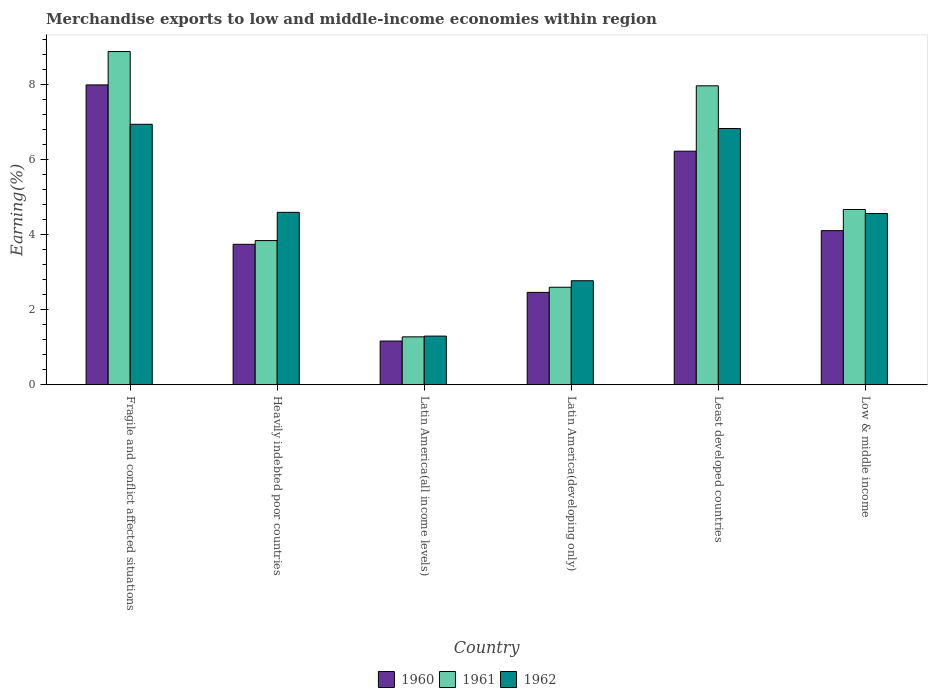How many different coloured bars are there?
Your answer should be very brief. 3. Are the number of bars per tick equal to the number of legend labels?
Your answer should be very brief. Yes. How many bars are there on the 1st tick from the left?
Ensure brevity in your answer.  3. How many bars are there on the 6th tick from the right?
Provide a short and direct response. 3. In how many cases, is the number of bars for a given country not equal to the number of legend labels?
Give a very brief answer. 0. What is the percentage of amount earned from merchandise exports in 1961 in Latin America(developing only)?
Your response must be concise. 2.6. Across all countries, what is the maximum percentage of amount earned from merchandise exports in 1961?
Offer a very short reply. 8.89. Across all countries, what is the minimum percentage of amount earned from merchandise exports in 1961?
Offer a terse response. 1.28. In which country was the percentage of amount earned from merchandise exports in 1960 maximum?
Ensure brevity in your answer.  Fragile and conflict affected situations. In which country was the percentage of amount earned from merchandise exports in 1960 minimum?
Make the answer very short. Latin America(all income levels). What is the total percentage of amount earned from merchandise exports in 1962 in the graph?
Give a very brief answer. 27.04. What is the difference between the percentage of amount earned from merchandise exports in 1961 in Heavily indebted poor countries and that in Low & middle income?
Make the answer very short. -0.83. What is the difference between the percentage of amount earned from merchandise exports in 1962 in Least developed countries and the percentage of amount earned from merchandise exports in 1961 in Latin America(developing only)?
Offer a very short reply. 4.23. What is the average percentage of amount earned from merchandise exports in 1961 per country?
Provide a short and direct response. 4.88. What is the difference between the percentage of amount earned from merchandise exports of/in 1961 and percentage of amount earned from merchandise exports of/in 1962 in Latin America(developing only)?
Provide a succinct answer. -0.17. In how many countries, is the percentage of amount earned from merchandise exports in 1961 greater than 6.8 %?
Offer a very short reply. 2. What is the ratio of the percentage of amount earned from merchandise exports in 1960 in Heavily indebted poor countries to that in Least developed countries?
Make the answer very short. 0.6. Is the percentage of amount earned from merchandise exports in 1960 in Heavily indebted poor countries less than that in Low & middle income?
Provide a short and direct response. Yes. Is the difference between the percentage of amount earned from merchandise exports in 1961 in Heavily indebted poor countries and Latin America(all income levels) greater than the difference between the percentage of amount earned from merchandise exports in 1962 in Heavily indebted poor countries and Latin America(all income levels)?
Offer a very short reply. No. What is the difference between the highest and the second highest percentage of amount earned from merchandise exports in 1961?
Keep it short and to the point. 4.21. What is the difference between the highest and the lowest percentage of amount earned from merchandise exports in 1961?
Make the answer very short. 7.61. In how many countries, is the percentage of amount earned from merchandise exports in 1962 greater than the average percentage of amount earned from merchandise exports in 1962 taken over all countries?
Give a very brief answer. 4. Is the sum of the percentage of amount earned from merchandise exports in 1962 in Latin America(developing only) and Least developed countries greater than the maximum percentage of amount earned from merchandise exports in 1961 across all countries?
Your answer should be compact. Yes. What does the 3rd bar from the left in Low & middle income represents?
Offer a very short reply. 1962. What does the 2nd bar from the right in Latin America(developing only) represents?
Make the answer very short. 1961. How many bars are there?
Keep it short and to the point. 18. What is the difference between two consecutive major ticks on the Y-axis?
Keep it short and to the point. 2. Does the graph contain any zero values?
Offer a terse response. No. Where does the legend appear in the graph?
Your answer should be compact. Bottom center. How many legend labels are there?
Make the answer very short. 3. How are the legend labels stacked?
Make the answer very short. Horizontal. What is the title of the graph?
Your answer should be compact. Merchandise exports to low and middle-income economies within region. Does "2000" appear as one of the legend labels in the graph?
Offer a terse response. No. What is the label or title of the X-axis?
Your response must be concise. Country. What is the label or title of the Y-axis?
Offer a very short reply. Earning(%). What is the Earning(%) of 1960 in Fragile and conflict affected situations?
Make the answer very short. 8. What is the Earning(%) of 1961 in Fragile and conflict affected situations?
Your answer should be very brief. 8.89. What is the Earning(%) in 1962 in Fragile and conflict affected situations?
Your response must be concise. 6.95. What is the Earning(%) of 1960 in Heavily indebted poor countries?
Give a very brief answer. 3.75. What is the Earning(%) of 1961 in Heavily indebted poor countries?
Offer a very short reply. 3.85. What is the Earning(%) of 1962 in Heavily indebted poor countries?
Your answer should be very brief. 4.6. What is the Earning(%) in 1960 in Latin America(all income levels)?
Keep it short and to the point. 1.17. What is the Earning(%) in 1961 in Latin America(all income levels)?
Ensure brevity in your answer.  1.28. What is the Earning(%) of 1962 in Latin America(all income levels)?
Offer a terse response. 1.3. What is the Earning(%) of 1960 in Latin America(developing only)?
Provide a succinct answer. 2.47. What is the Earning(%) in 1961 in Latin America(developing only)?
Offer a very short reply. 2.6. What is the Earning(%) of 1962 in Latin America(developing only)?
Offer a terse response. 2.78. What is the Earning(%) in 1960 in Least developed countries?
Ensure brevity in your answer.  6.23. What is the Earning(%) in 1961 in Least developed countries?
Provide a short and direct response. 7.98. What is the Earning(%) in 1962 in Least developed countries?
Offer a very short reply. 6.84. What is the Earning(%) in 1960 in Low & middle income?
Make the answer very short. 4.11. What is the Earning(%) in 1961 in Low & middle income?
Your answer should be compact. 4.68. What is the Earning(%) of 1962 in Low & middle income?
Provide a short and direct response. 4.57. Across all countries, what is the maximum Earning(%) of 1960?
Your answer should be very brief. 8. Across all countries, what is the maximum Earning(%) in 1961?
Your response must be concise. 8.89. Across all countries, what is the maximum Earning(%) of 1962?
Offer a very short reply. 6.95. Across all countries, what is the minimum Earning(%) of 1960?
Make the answer very short. 1.17. Across all countries, what is the minimum Earning(%) of 1961?
Give a very brief answer. 1.28. Across all countries, what is the minimum Earning(%) in 1962?
Your answer should be compact. 1.3. What is the total Earning(%) in 1960 in the graph?
Your answer should be very brief. 25.74. What is the total Earning(%) of 1961 in the graph?
Provide a succinct answer. 29.28. What is the total Earning(%) of 1962 in the graph?
Provide a short and direct response. 27.04. What is the difference between the Earning(%) of 1960 in Fragile and conflict affected situations and that in Heavily indebted poor countries?
Make the answer very short. 4.25. What is the difference between the Earning(%) in 1961 in Fragile and conflict affected situations and that in Heavily indebted poor countries?
Your response must be concise. 5.04. What is the difference between the Earning(%) of 1962 in Fragile and conflict affected situations and that in Heavily indebted poor countries?
Keep it short and to the point. 2.35. What is the difference between the Earning(%) in 1960 in Fragile and conflict affected situations and that in Latin America(all income levels)?
Provide a short and direct response. 6.83. What is the difference between the Earning(%) in 1961 in Fragile and conflict affected situations and that in Latin America(all income levels)?
Your response must be concise. 7.61. What is the difference between the Earning(%) in 1962 in Fragile and conflict affected situations and that in Latin America(all income levels)?
Give a very brief answer. 5.65. What is the difference between the Earning(%) in 1960 in Fragile and conflict affected situations and that in Latin America(developing only)?
Your answer should be very brief. 5.53. What is the difference between the Earning(%) in 1961 in Fragile and conflict affected situations and that in Latin America(developing only)?
Your response must be concise. 6.29. What is the difference between the Earning(%) in 1962 in Fragile and conflict affected situations and that in Latin America(developing only)?
Your response must be concise. 4.17. What is the difference between the Earning(%) of 1960 in Fragile and conflict affected situations and that in Least developed countries?
Your answer should be compact. 1.77. What is the difference between the Earning(%) of 1961 in Fragile and conflict affected situations and that in Least developed countries?
Offer a very short reply. 0.91. What is the difference between the Earning(%) of 1962 in Fragile and conflict affected situations and that in Least developed countries?
Offer a very short reply. 0.11. What is the difference between the Earning(%) in 1960 in Fragile and conflict affected situations and that in Low & middle income?
Keep it short and to the point. 3.89. What is the difference between the Earning(%) of 1961 in Fragile and conflict affected situations and that in Low & middle income?
Offer a terse response. 4.21. What is the difference between the Earning(%) in 1962 in Fragile and conflict affected situations and that in Low & middle income?
Your answer should be compact. 2.38. What is the difference between the Earning(%) in 1960 in Heavily indebted poor countries and that in Latin America(all income levels)?
Provide a succinct answer. 2.58. What is the difference between the Earning(%) of 1961 in Heavily indebted poor countries and that in Latin America(all income levels)?
Your answer should be very brief. 2.57. What is the difference between the Earning(%) of 1962 in Heavily indebted poor countries and that in Latin America(all income levels)?
Ensure brevity in your answer.  3.3. What is the difference between the Earning(%) of 1960 in Heavily indebted poor countries and that in Latin America(developing only)?
Ensure brevity in your answer.  1.28. What is the difference between the Earning(%) of 1961 in Heavily indebted poor countries and that in Latin America(developing only)?
Provide a short and direct response. 1.24. What is the difference between the Earning(%) of 1962 in Heavily indebted poor countries and that in Latin America(developing only)?
Provide a short and direct response. 1.82. What is the difference between the Earning(%) of 1960 in Heavily indebted poor countries and that in Least developed countries?
Provide a short and direct response. -2.48. What is the difference between the Earning(%) of 1961 in Heavily indebted poor countries and that in Least developed countries?
Provide a succinct answer. -4.13. What is the difference between the Earning(%) of 1962 in Heavily indebted poor countries and that in Least developed countries?
Provide a succinct answer. -2.24. What is the difference between the Earning(%) in 1960 in Heavily indebted poor countries and that in Low & middle income?
Your response must be concise. -0.36. What is the difference between the Earning(%) in 1961 in Heavily indebted poor countries and that in Low & middle income?
Offer a terse response. -0.83. What is the difference between the Earning(%) in 1962 in Heavily indebted poor countries and that in Low & middle income?
Offer a very short reply. 0.03. What is the difference between the Earning(%) of 1960 in Latin America(all income levels) and that in Latin America(developing only)?
Keep it short and to the point. -1.3. What is the difference between the Earning(%) of 1961 in Latin America(all income levels) and that in Latin America(developing only)?
Your response must be concise. -1.32. What is the difference between the Earning(%) of 1962 in Latin America(all income levels) and that in Latin America(developing only)?
Your answer should be compact. -1.48. What is the difference between the Earning(%) in 1960 in Latin America(all income levels) and that in Least developed countries?
Ensure brevity in your answer.  -5.06. What is the difference between the Earning(%) of 1961 in Latin America(all income levels) and that in Least developed countries?
Make the answer very short. -6.7. What is the difference between the Earning(%) of 1962 in Latin America(all income levels) and that in Least developed countries?
Your answer should be compact. -5.54. What is the difference between the Earning(%) of 1960 in Latin America(all income levels) and that in Low & middle income?
Your answer should be compact. -2.94. What is the difference between the Earning(%) in 1961 in Latin America(all income levels) and that in Low & middle income?
Provide a short and direct response. -3.4. What is the difference between the Earning(%) in 1962 in Latin America(all income levels) and that in Low & middle income?
Provide a short and direct response. -3.27. What is the difference between the Earning(%) of 1960 in Latin America(developing only) and that in Least developed countries?
Make the answer very short. -3.77. What is the difference between the Earning(%) of 1961 in Latin America(developing only) and that in Least developed countries?
Ensure brevity in your answer.  -5.37. What is the difference between the Earning(%) in 1962 in Latin America(developing only) and that in Least developed countries?
Provide a short and direct response. -4.06. What is the difference between the Earning(%) of 1960 in Latin America(developing only) and that in Low & middle income?
Provide a short and direct response. -1.65. What is the difference between the Earning(%) of 1961 in Latin America(developing only) and that in Low & middle income?
Provide a succinct answer. -2.07. What is the difference between the Earning(%) of 1962 in Latin America(developing only) and that in Low & middle income?
Provide a short and direct response. -1.79. What is the difference between the Earning(%) of 1960 in Least developed countries and that in Low & middle income?
Your answer should be very brief. 2.12. What is the difference between the Earning(%) of 1961 in Least developed countries and that in Low & middle income?
Give a very brief answer. 3.3. What is the difference between the Earning(%) in 1962 in Least developed countries and that in Low & middle income?
Offer a very short reply. 2.27. What is the difference between the Earning(%) in 1960 in Fragile and conflict affected situations and the Earning(%) in 1961 in Heavily indebted poor countries?
Give a very brief answer. 4.15. What is the difference between the Earning(%) of 1960 in Fragile and conflict affected situations and the Earning(%) of 1962 in Heavily indebted poor countries?
Make the answer very short. 3.4. What is the difference between the Earning(%) in 1961 in Fragile and conflict affected situations and the Earning(%) in 1962 in Heavily indebted poor countries?
Offer a terse response. 4.29. What is the difference between the Earning(%) of 1960 in Fragile and conflict affected situations and the Earning(%) of 1961 in Latin America(all income levels)?
Make the answer very short. 6.72. What is the difference between the Earning(%) of 1960 in Fragile and conflict affected situations and the Earning(%) of 1962 in Latin America(all income levels)?
Your answer should be very brief. 6.7. What is the difference between the Earning(%) of 1961 in Fragile and conflict affected situations and the Earning(%) of 1962 in Latin America(all income levels)?
Provide a succinct answer. 7.59. What is the difference between the Earning(%) of 1960 in Fragile and conflict affected situations and the Earning(%) of 1961 in Latin America(developing only)?
Your answer should be very brief. 5.4. What is the difference between the Earning(%) in 1960 in Fragile and conflict affected situations and the Earning(%) in 1962 in Latin America(developing only)?
Your response must be concise. 5.22. What is the difference between the Earning(%) in 1961 in Fragile and conflict affected situations and the Earning(%) in 1962 in Latin America(developing only)?
Your answer should be very brief. 6.11. What is the difference between the Earning(%) in 1960 in Fragile and conflict affected situations and the Earning(%) in 1961 in Least developed countries?
Ensure brevity in your answer.  0.02. What is the difference between the Earning(%) of 1960 in Fragile and conflict affected situations and the Earning(%) of 1962 in Least developed countries?
Keep it short and to the point. 1.16. What is the difference between the Earning(%) of 1961 in Fragile and conflict affected situations and the Earning(%) of 1962 in Least developed countries?
Offer a terse response. 2.05. What is the difference between the Earning(%) in 1960 in Fragile and conflict affected situations and the Earning(%) in 1961 in Low & middle income?
Provide a short and direct response. 3.32. What is the difference between the Earning(%) in 1960 in Fragile and conflict affected situations and the Earning(%) in 1962 in Low & middle income?
Your answer should be compact. 3.43. What is the difference between the Earning(%) of 1961 in Fragile and conflict affected situations and the Earning(%) of 1962 in Low & middle income?
Offer a very short reply. 4.32. What is the difference between the Earning(%) of 1960 in Heavily indebted poor countries and the Earning(%) of 1961 in Latin America(all income levels)?
Keep it short and to the point. 2.47. What is the difference between the Earning(%) in 1960 in Heavily indebted poor countries and the Earning(%) in 1962 in Latin America(all income levels)?
Provide a short and direct response. 2.45. What is the difference between the Earning(%) of 1961 in Heavily indebted poor countries and the Earning(%) of 1962 in Latin America(all income levels)?
Offer a very short reply. 2.55. What is the difference between the Earning(%) in 1960 in Heavily indebted poor countries and the Earning(%) in 1961 in Latin America(developing only)?
Make the answer very short. 1.15. What is the difference between the Earning(%) in 1960 in Heavily indebted poor countries and the Earning(%) in 1962 in Latin America(developing only)?
Ensure brevity in your answer.  0.97. What is the difference between the Earning(%) in 1961 in Heavily indebted poor countries and the Earning(%) in 1962 in Latin America(developing only)?
Make the answer very short. 1.07. What is the difference between the Earning(%) in 1960 in Heavily indebted poor countries and the Earning(%) in 1961 in Least developed countries?
Your answer should be compact. -4.23. What is the difference between the Earning(%) of 1960 in Heavily indebted poor countries and the Earning(%) of 1962 in Least developed countries?
Provide a short and direct response. -3.09. What is the difference between the Earning(%) of 1961 in Heavily indebted poor countries and the Earning(%) of 1962 in Least developed countries?
Offer a very short reply. -2.99. What is the difference between the Earning(%) of 1960 in Heavily indebted poor countries and the Earning(%) of 1961 in Low & middle income?
Your answer should be compact. -0.93. What is the difference between the Earning(%) of 1960 in Heavily indebted poor countries and the Earning(%) of 1962 in Low & middle income?
Make the answer very short. -0.82. What is the difference between the Earning(%) in 1961 in Heavily indebted poor countries and the Earning(%) in 1962 in Low & middle income?
Provide a succinct answer. -0.72. What is the difference between the Earning(%) of 1960 in Latin America(all income levels) and the Earning(%) of 1961 in Latin America(developing only)?
Give a very brief answer. -1.43. What is the difference between the Earning(%) of 1960 in Latin America(all income levels) and the Earning(%) of 1962 in Latin America(developing only)?
Provide a succinct answer. -1.61. What is the difference between the Earning(%) of 1961 in Latin America(all income levels) and the Earning(%) of 1962 in Latin America(developing only)?
Keep it short and to the point. -1.5. What is the difference between the Earning(%) of 1960 in Latin America(all income levels) and the Earning(%) of 1961 in Least developed countries?
Your response must be concise. -6.81. What is the difference between the Earning(%) in 1960 in Latin America(all income levels) and the Earning(%) in 1962 in Least developed countries?
Your answer should be compact. -5.67. What is the difference between the Earning(%) of 1961 in Latin America(all income levels) and the Earning(%) of 1962 in Least developed countries?
Your answer should be very brief. -5.56. What is the difference between the Earning(%) of 1960 in Latin America(all income levels) and the Earning(%) of 1961 in Low & middle income?
Your answer should be compact. -3.51. What is the difference between the Earning(%) of 1960 in Latin America(all income levels) and the Earning(%) of 1962 in Low & middle income?
Make the answer very short. -3.4. What is the difference between the Earning(%) of 1961 in Latin America(all income levels) and the Earning(%) of 1962 in Low & middle income?
Provide a short and direct response. -3.29. What is the difference between the Earning(%) in 1960 in Latin America(developing only) and the Earning(%) in 1961 in Least developed countries?
Keep it short and to the point. -5.51. What is the difference between the Earning(%) of 1960 in Latin America(developing only) and the Earning(%) of 1962 in Least developed countries?
Ensure brevity in your answer.  -4.37. What is the difference between the Earning(%) in 1961 in Latin America(developing only) and the Earning(%) in 1962 in Least developed countries?
Your response must be concise. -4.23. What is the difference between the Earning(%) of 1960 in Latin America(developing only) and the Earning(%) of 1961 in Low & middle income?
Your answer should be compact. -2.21. What is the difference between the Earning(%) in 1960 in Latin America(developing only) and the Earning(%) in 1962 in Low & middle income?
Make the answer very short. -2.1. What is the difference between the Earning(%) in 1961 in Latin America(developing only) and the Earning(%) in 1962 in Low & middle income?
Provide a short and direct response. -1.97. What is the difference between the Earning(%) in 1960 in Least developed countries and the Earning(%) in 1961 in Low & middle income?
Your answer should be compact. 1.56. What is the difference between the Earning(%) of 1960 in Least developed countries and the Earning(%) of 1962 in Low & middle income?
Provide a succinct answer. 1.66. What is the difference between the Earning(%) in 1961 in Least developed countries and the Earning(%) in 1962 in Low & middle income?
Provide a short and direct response. 3.41. What is the average Earning(%) in 1960 per country?
Your response must be concise. 4.29. What is the average Earning(%) in 1961 per country?
Offer a terse response. 4.88. What is the average Earning(%) of 1962 per country?
Make the answer very short. 4.51. What is the difference between the Earning(%) in 1960 and Earning(%) in 1961 in Fragile and conflict affected situations?
Give a very brief answer. -0.89. What is the difference between the Earning(%) of 1960 and Earning(%) of 1962 in Fragile and conflict affected situations?
Provide a succinct answer. 1.05. What is the difference between the Earning(%) of 1961 and Earning(%) of 1962 in Fragile and conflict affected situations?
Your answer should be very brief. 1.94. What is the difference between the Earning(%) of 1960 and Earning(%) of 1961 in Heavily indebted poor countries?
Provide a succinct answer. -0.1. What is the difference between the Earning(%) of 1960 and Earning(%) of 1962 in Heavily indebted poor countries?
Offer a terse response. -0.85. What is the difference between the Earning(%) in 1961 and Earning(%) in 1962 in Heavily indebted poor countries?
Your response must be concise. -0.75. What is the difference between the Earning(%) in 1960 and Earning(%) in 1961 in Latin America(all income levels)?
Make the answer very short. -0.11. What is the difference between the Earning(%) in 1960 and Earning(%) in 1962 in Latin America(all income levels)?
Ensure brevity in your answer.  -0.13. What is the difference between the Earning(%) of 1961 and Earning(%) of 1962 in Latin America(all income levels)?
Offer a terse response. -0.02. What is the difference between the Earning(%) of 1960 and Earning(%) of 1961 in Latin America(developing only)?
Your answer should be compact. -0.14. What is the difference between the Earning(%) in 1960 and Earning(%) in 1962 in Latin America(developing only)?
Ensure brevity in your answer.  -0.31. What is the difference between the Earning(%) of 1961 and Earning(%) of 1962 in Latin America(developing only)?
Make the answer very short. -0.17. What is the difference between the Earning(%) of 1960 and Earning(%) of 1961 in Least developed countries?
Offer a terse response. -1.74. What is the difference between the Earning(%) in 1960 and Earning(%) in 1962 in Least developed countries?
Give a very brief answer. -0.6. What is the difference between the Earning(%) in 1961 and Earning(%) in 1962 in Least developed countries?
Keep it short and to the point. 1.14. What is the difference between the Earning(%) of 1960 and Earning(%) of 1961 in Low & middle income?
Offer a terse response. -0.56. What is the difference between the Earning(%) in 1960 and Earning(%) in 1962 in Low & middle income?
Make the answer very short. -0.46. What is the difference between the Earning(%) of 1961 and Earning(%) of 1962 in Low & middle income?
Your answer should be compact. 0.11. What is the ratio of the Earning(%) of 1960 in Fragile and conflict affected situations to that in Heavily indebted poor countries?
Your response must be concise. 2.13. What is the ratio of the Earning(%) of 1961 in Fragile and conflict affected situations to that in Heavily indebted poor countries?
Provide a succinct answer. 2.31. What is the ratio of the Earning(%) in 1962 in Fragile and conflict affected situations to that in Heavily indebted poor countries?
Give a very brief answer. 1.51. What is the ratio of the Earning(%) of 1960 in Fragile and conflict affected situations to that in Latin America(all income levels)?
Your response must be concise. 6.84. What is the ratio of the Earning(%) in 1961 in Fragile and conflict affected situations to that in Latin America(all income levels)?
Give a very brief answer. 6.94. What is the ratio of the Earning(%) in 1962 in Fragile and conflict affected situations to that in Latin America(all income levels)?
Ensure brevity in your answer.  5.34. What is the ratio of the Earning(%) of 1960 in Fragile and conflict affected situations to that in Latin America(developing only)?
Offer a terse response. 3.24. What is the ratio of the Earning(%) in 1961 in Fragile and conflict affected situations to that in Latin America(developing only)?
Make the answer very short. 3.41. What is the ratio of the Earning(%) of 1962 in Fragile and conflict affected situations to that in Latin America(developing only)?
Provide a short and direct response. 2.5. What is the ratio of the Earning(%) of 1960 in Fragile and conflict affected situations to that in Least developed countries?
Your response must be concise. 1.28. What is the ratio of the Earning(%) of 1961 in Fragile and conflict affected situations to that in Least developed countries?
Ensure brevity in your answer.  1.11. What is the ratio of the Earning(%) of 1962 in Fragile and conflict affected situations to that in Least developed countries?
Ensure brevity in your answer.  1.02. What is the ratio of the Earning(%) of 1960 in Fragile and conflict affected situations to that in Low & middle income?
Keep it short and to the point. 1.94. What is the ratio of the Earning(%) of 1961 in Fragile and conflict affected situations to that in Low & middle income?
Your answer should be very brief. 1.9. What is the ratio of the Earning(%) of 1962 in Fragile and conflict affected situations to that in Low & middle income?
Give a very brief answer. 1.52. What is the ratio of the Earning(%) of 1960 in Heavily indebted poor countries to that in Latin America(all income levels)?
Offer a terse response. 3.2. What is the ratio of the Earning(%) in 1961 in Heavily indebted poor countries to that in Latin America(all income levels)?
Provide a succinct answer. 3. What is the ratio of the Earning(%) of 1962 in Heavily indebted poor countries to that in Latin America(all income levels)?
Your answer should be compact. 3.54. What is the ratio of the Earning(%) in 1960 in Heavily indebted poor countries to that in Latin America(developing only)?
Your answer should be compact. 1.52. What is the ratio of the Earning(%) in 1961 in Heavily indebted poor countries to that in Latin America(developing only)?
Your answer should be compact. 1.48. What is the ratio of the Earning(%) of 1962 in Heavily indebted poor countries to that in Latin America(developing only)?
Provide a short and direct response. 1.66. What is the ratio of the Earning(%) in 1960 in Heavily indebted poor countries to that in Least developed countries?
Keep it short and to the point. 0.6. What is the ratio of the Earning(%) of 1961 in Heavily indebted poor countries to that in Least developed countries?
Provide a short and direct response. 0.48. What is the ratio of the Earning(%) of 1962 in Heavily indebted poor countries to that in Least developed countries?
Ensure brevity in your answer.  0.67. What is the ratio of the Earning(%) in 1960 in Heavily indebted poor countries to that in Low & middle income?
Offer a very short reply. 0.91. What is the ratio of the Earning(%) of 1961 in Heavily indebted poor countries to that in Low & middle income?
Offer a very short reply. 0.82. What is the ratio of the Earning(%) of 1962 in Heavily indebted poor countries to that in Low & middle income?
Provide a short and direct response. 1.01. What is the ratio of the Earning(%) of 1960 in Latin America(all income levels) to that in Latin America(developing only)?
Ensure brevity in your answer.  0.47. What is the ratio of the Earning(%) in 1961 in Latin America(all income levels) to that in Latin America(developing only)?
Your answer should be very brief. 0.49. What is the ratio of the Earning(%) in 1962 in Latin America(all income levels) to that in Latin America(developing only)?
Your answer should be very brief. 0.47. What is the ratio of the Earning(%) of 1960 in Latin America(all income levels) to that in Least developed countries?
Your answer should be very brief. 0.19. What is the ratio of the Earning(%) in 1961 in Latin America(all income levels) to that in Least developed countries?
Provide a short and direct response. 0.16. What is the ratio of the Earning(%) in 1962 in Latin America(all income levels) to that in Least developed countries?
Provide a short and direct response. 0.19. What is the ratio of the Earning(%) in 1960 in Latin America(all income levels) to that in Low & middle income?
Your response must be concise. 0.28. What is the ratio of the Earning(%) in 1961 in Latin America(all income levels) to that in Low & middle income?
Give a very brief answer. 0.27. What is the ratio of the Earning(%) of 1962 in Latin America(all income levels) to that in Low & middle income?
Your response must be concise. 0.28. What is the ratio of the Earning(%) in 1960 in Latin America(developing only) to that in Least developed countries?
Give a very brief answer. 0.4. What is the ratio of the Earning(%) of 1961 in Latin America(developing only) to that in Least developed countries?
Provide a succinct answer. 0.33. What is the ratio of the Earning(%) in 1962 in Latin America(developing only) to that in Least developed countries?
Make the answer very short. 0.41. What is the ratio of the Earning(%) of 1960 in Latin America(developing only) to that in Low & middle income?
Keep it short and to the point. 0.6. What is the ratio of the Earning(%) in 1961 in Latin America(developing only) to that in Low & middle income?
Give a very brief answer. 0.56. What is the ratio of the Earning(%) of 1962 in Latin America(developing only) to that in Low & middle income?
Offer a terse response. 0.61. What is the ratio of the Earning(%) of 1960 in Least developed countries to that in Low & middle income?
Your response must be concise. 1.52. What is the ratio of the Earning(%) of 1961 in Least developed countries to that in Low & middle income?
Make the answer very short. 1.71. What is the ratio of the Earning(%) in 1962 in Least developed countries to that in Low & middle income?
Ensure brevity in your answer.  1.5. What is the difference between the highest and the second highest Earning(%) of 1960?
Offer a very short reply. 1.77. What is the difference between the highest and the second highest Earning(%) of 1961?
Keep it short and to the point. 0.91. What is the difference between the highest and the second highest Earning(%) in 1962?
Keep it short and to the point. 0.11. What is the difference between the highest and the lowest Earning(%) in 1960?
Provide a short and direct response. 6.83. What is the difference between the highest and the lowest Earning(%) in 1961?
Offer a terse response. 7.61. What is the difference between the highest and the lowest Earning(%) in 1962?
Your answer should be very brief. 5.65. 